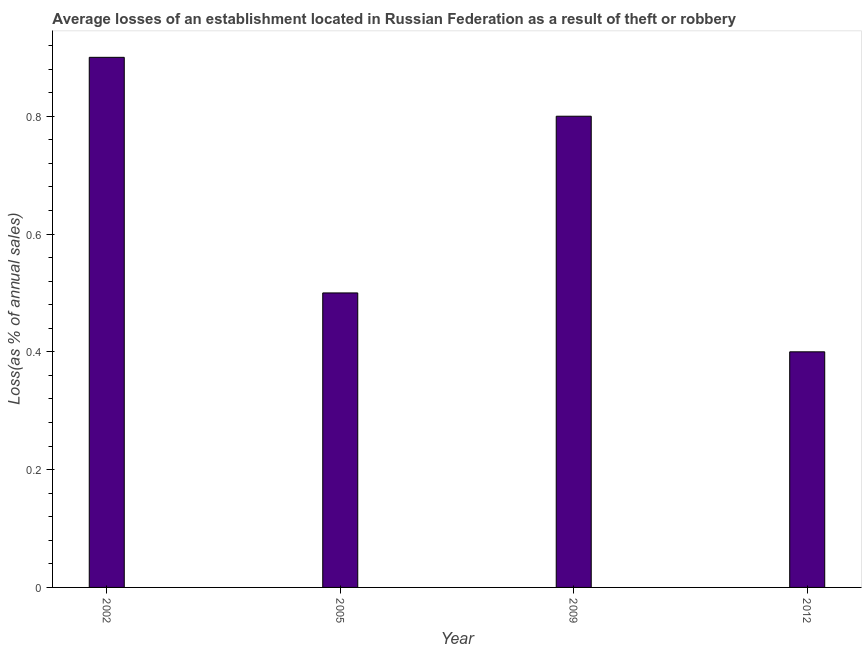Does the graph contain any zero values?
Your answer should be compact. No. What is the title of the graph?
Offer a terse response. Average losses of an establishment located in Russian Federation as a result of theft or robbery. What is the label or title of the Y-axis?
Your response must be concise. Loss(as % of annual sales). Across all years, what is the maximum losses due to theft?
Offer a very short reply. 0.9. In which year was the losses due to theft maximum?
Keep it short and to the point. 2002. What is the difference between the losses due to theft in 2009 and 2012?
Make the answer very short. 0.4. What is the average losses due to theft per year?
Your response must be concise. 0.65. What is the median losses due to theft?
Offer a terse response. 0.65. In how many years, is the losses due to theft greater than 0.12 %?
Your response must be concise. 4. Do a majority of the years between 2002 and 2005 (inclusive) have losses due to theft greater than 0.76 %?
Provide a short and direct response. No. What is the ratio of the losses due to theft in 2009 to that in 2012?
Your answer should be very brief. 2. What is the difference between the highest and the second highest losses due to theft?
Your answer should be very brief. 0.1. Is the sum of the losses due to theft in 2002 and 2009 greater than the maximum losses due to theft across all years?
Ensure brevity in your answer.  Yes. In how many years, is the losses due to theft greater than the average losses due to theft taken over all years?
Give a very brief answer. 2. How many years are there in the graph?
Offer a terse response. 4. What is the difference between two consecutive major ticks on the Y-axis?
Keep it short and to the point. 0.2. Are the values on the major ticks of Y-axis written in scientific E-notation?
Give a very brief answer. No. What is the Loss(as % of annual sales) in 2002?
Keep it short and to the point. 0.9. What is the Loss(as % of annual sales) in 2005?
Your answer should be very brief. 0.5. What is the Loss(as % of annual sales) in 2009?
Provide a succinct answer. 0.8. What is the difference between the Loss(as % of annual sales) in 2002 and 2009?
Give a very brief answer. 0.1. What is the difference between the Loss(as % of annual sales) in 2002 and 2012?
Offer a terse response. 0.5. What is the difference between the Loss(as % of annual sales) in 2005 and 2009?
Make the answer very short. -0.3. What is the difference between the Loss(as % of annual sales) in 2005 and 2012?
Your answer should be very brief. 0.1. What is the difference between the Loss(as % of annual sales) in 2009 and 2012?
Keep it short and to the point. 0.4. What is the ratio of the Loss(as % of annual sales) in 2002 to that in 2005?
Ensure brevity in your answer.  1.8. What is the ratio of the Loss(as % of annual sales) in 2002 to that in 2012?
Offer a very short reply. 2.25. What is the ratio of the Loss(as % of annual sales) in 2005 to that in 2009?
Offer a very short reply. 0.62. What is the ratio of the Loss(as % of annual sales) in 2009 to that in 2012?
Your answer should be very brief. 2. 